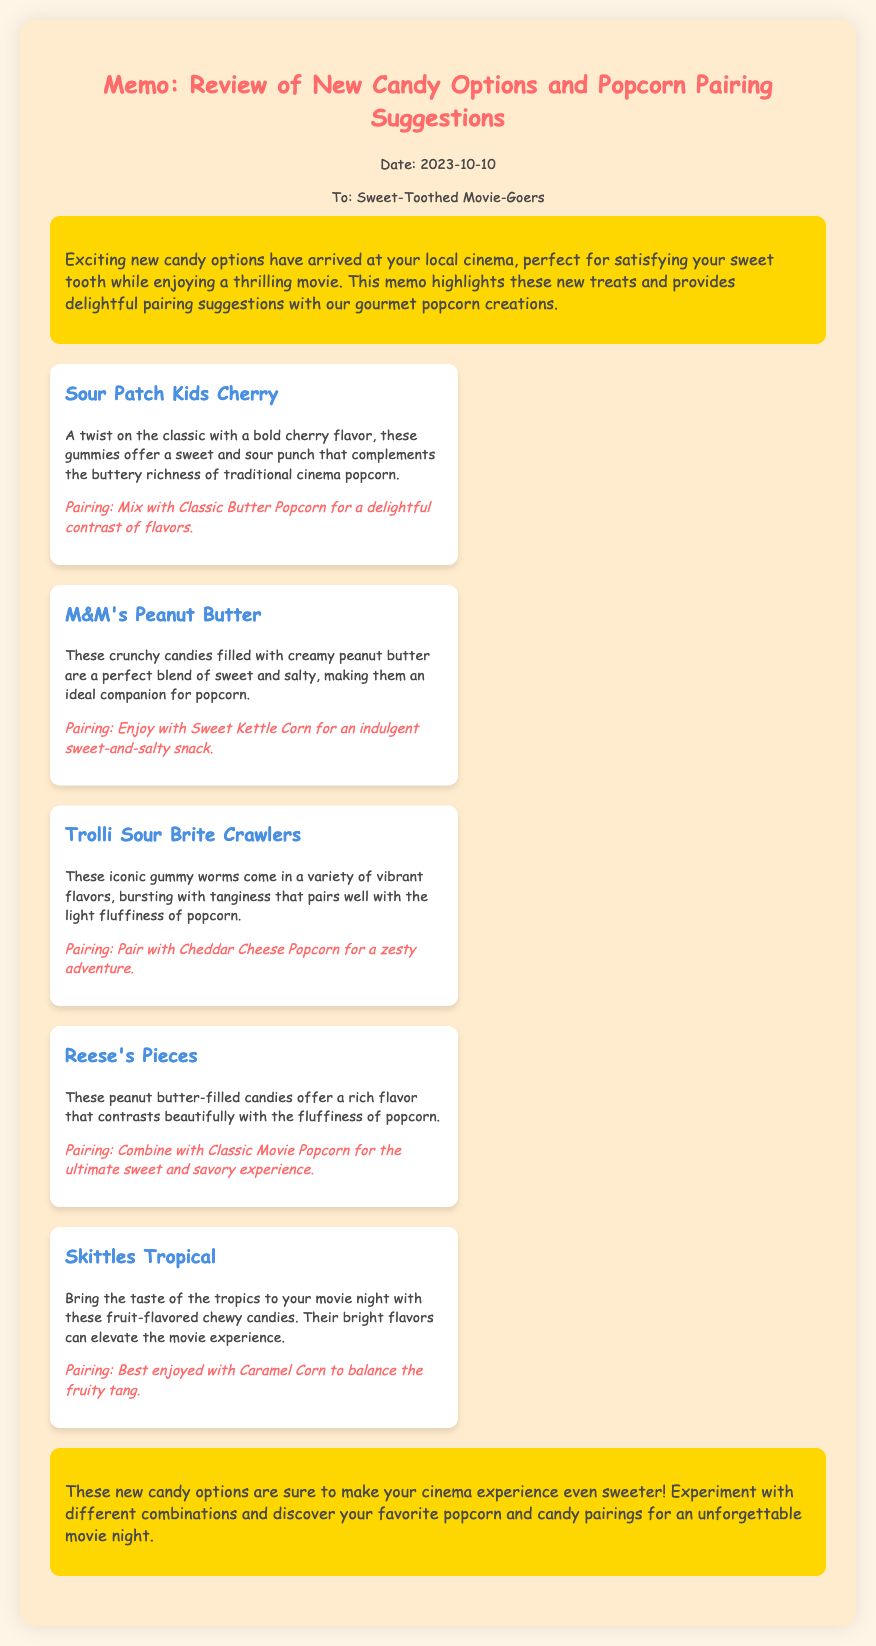what is the date of the memo? The date given in the document is found in the date section and is listed as 2023-10-10.
Answer: 2023-10-10 who is the intended audience for the memo? The audience is specified at the beginning of the memo and reads "Sweet-Toothed Movie-Goers."
Answer: Sweet-Toothed Movie-Goers what is the pairing suggestion for Sour Patch Kids Cherry? The pairing suggestion for Sour Patch Kids Cherry is mentioned directly in the candy item details.
Answer: Mix with Classic Butter Popcorn how many new candy options are reviewed in the memo? The document outlines five new candy options, indicated by the number of candy items listed.
Answer: Five which popcorn flavor pairs best with Skittles Tropical? The popcorn flavor that best pairs with Skittles Tropical is found in the pairing section tied to that candy item.
Answer: Caramel Corn what type of candy is Reese’s Pieces? The type of candy is categorized in the description along with its key characteristic, which is as a filled candy.
Answer: Peanut butter-filled what flavor combination is suggested for M&M's Peanut Butter? The suggested flavor combination is conveyed in the pairing section directly linked to that candy item.
Answer: Sweet Kettle Corn what is the main purpose of the memo? The main purpose is stated in the introductory section, summarizing the memo's intent.
Answer: To highlight new treats and pairing suggestions what candy is described as having a variety of vibrant flavors? The candy described with vibrant flavors is mentioned in the respective candy item details.
Answer: Trolli Sour Brite Crawlers 